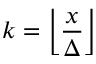<formula> <loc_0><loc_0><loc_500><loc_500>k = \left \lfloor { \frac { x } { \Delta } } \right \rfloor</formula> 